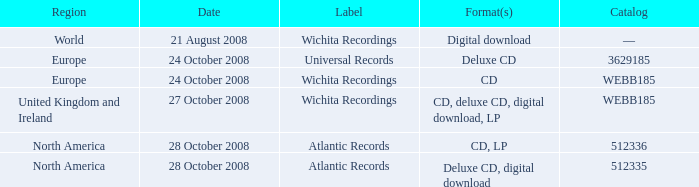In which area does the catalog value 512335 correspond to? North America. 